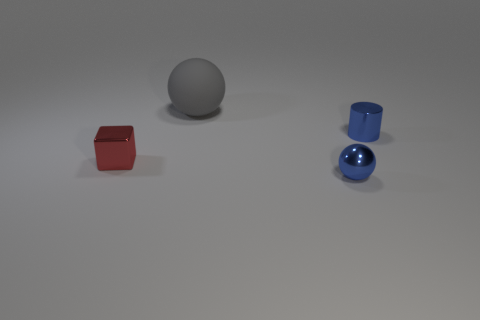Add 2 shiny cylinders. How many objects exist? 6 Subtract all gray balls. How many balls are left? 1 Subtract all cylinders. How many objects are left? 3 Subtract 1 cylinders. How many cylinders are left? 0 Add 4 small objects. How many small objects exist? 7 Subtract 0 purple blocks. How many objects are left? 4 Subtract all green blocks. Subtract all blue balls. How many blocks are left? 1 Subtract all purple cylinders. How many blue spheres are left? 1 Subtract all purple metallic cubes. Subtract all blue metal things. How many objects are left? 2 Add 3 large objects. How many large objects are left? 4 